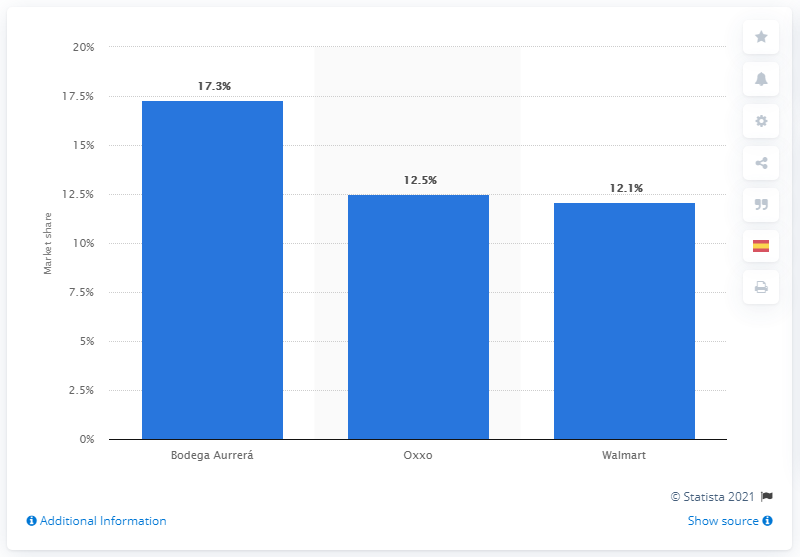Specify some key components in this picture. Walmart is the largest retailer in Mexico City. 